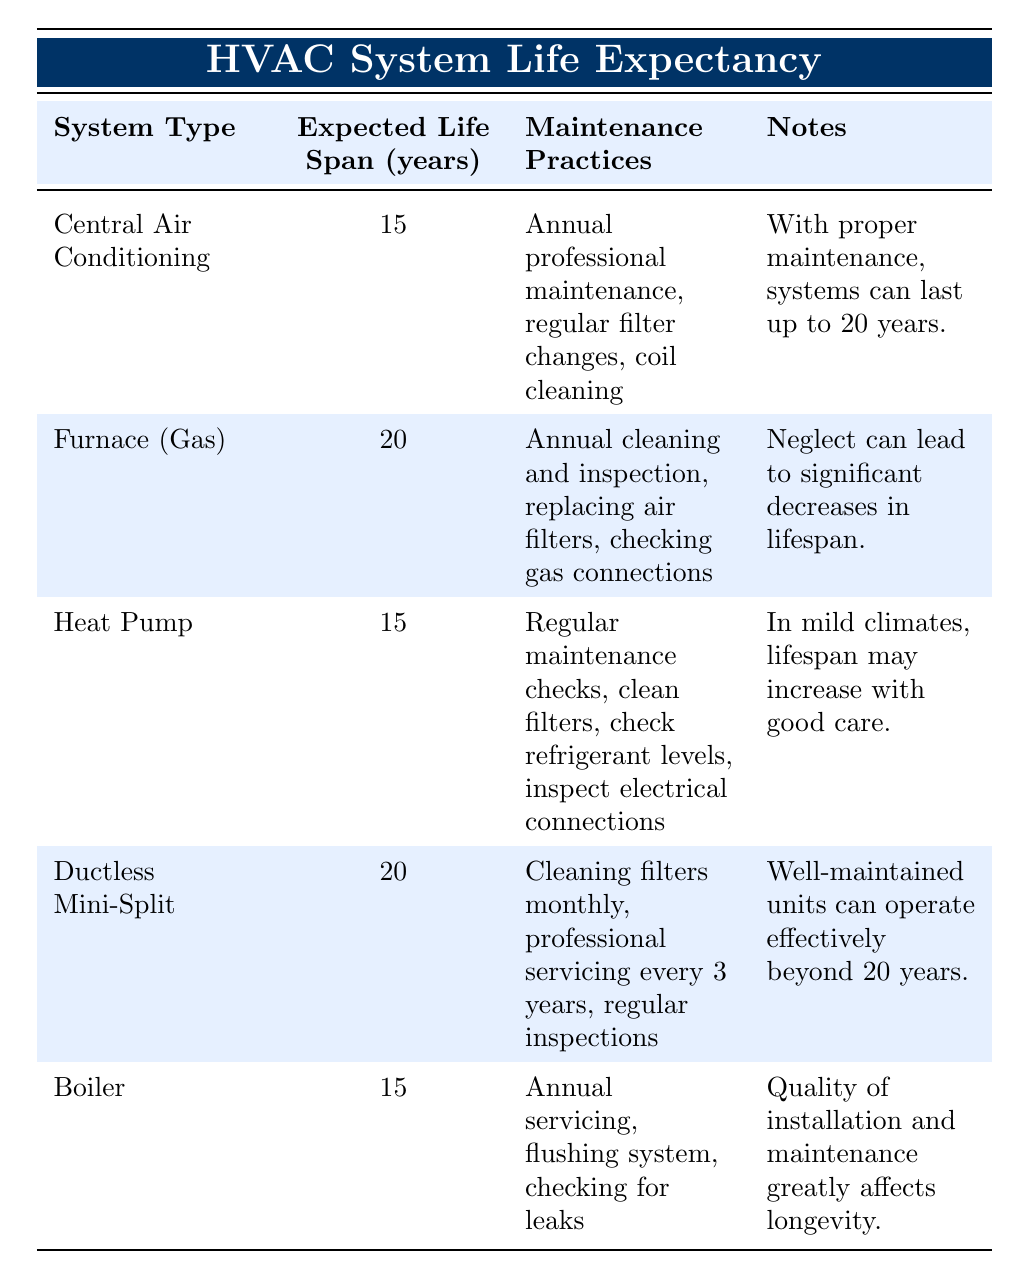What's the expected life span of a Central Air Conditioning system? The table indicates that the expected life span of a Central Air Conditioning system is listed as 15 years in the corresponding row.
Answer: 15 years How many years longer can a Furnace (Gas) last compared to a Heat Pump? A Furnace (Gas) has an expected life span of 20 years, while a Heat Pump has an expected life span of 15 years. Subtracting the two gives 20 - 15 = 5 years.
Answer: 5 years Is it true that with proper maintenance, a Ductless Mini-Split can last beyond 20 years? The notes section for the Ductless Mini-Split states that well-maintained units can operate effectively beyond 20 years, which confirms that the statement is true.
Answer: Yes What is the average expected life span of all the HVAC systems listed? To find the average, sum the expected life spans: 15 + 20 + 15 + 20 + 15 = 85. There are 5 systems, so the average is 85 / 5 = 17 years.
Answer: 17 years Does the table suggest that neglecting maintenance can affect the lifespan of HVAC systems? Yes, the notes for the Furnace (Gas) clearly state that neglect can lead to significant decreases in lifespan, and similar implications can be inferred from other systems.
Answer: Yes Which system has the longest expected life span and what are its maintenance practices? The Furnace (Gas) and Ductless Mini-Split both have the longest expected life span of 20 years. The maintenance practices for the Furnace (Gas) include annual cleaning and inspection, replacing air filters, and checking gas connections, while for the Ductless Mini-Split, it involves monthly filter cleaning, professional servicing every 3 years, and regular inspections.
Answer: Ductless Mini-Split, annual cleaning and inspection, filter changes, gas connections What are the expected life spans of systems that require annual maintenance? The systems requiring annual maintenance are the Central Air Conditioning with 15 years, Furnace (Gas) with 20 years, Heat Pump with 15 years, and Boiler with 15 years. Summing up these values: 15 + 20 + 15 + 15 = 65 years.
Answer: 65 years How many HVAC systems have an expected life span of 15 years? There are three systems listed with an expected life span of 15 years: Central Air Conditioning, Heat Pump, and Boiler.
Answer: 3 systems Is regular filter cleaning necessary for both Ductless Mini-Split and Heat Pump systems? Yes, the Ductless Mini-Split requires monthly cleaning of filters, and the Heat Pump requires cleaning of filters regularly as part of its maintenance practices.
Answer: Yes 